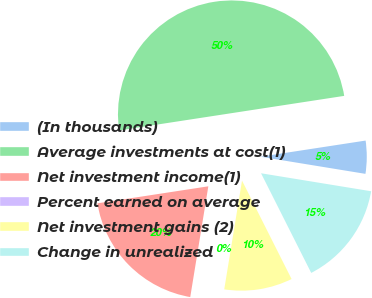Convert chart. <chart><loc_0><loc_0><loc_500><loc_500><pie_chart><fcel>(In thousands)<fcel>Average investments at cost(1)<fcel>Net investment income(1)<fcel>Percent earned on average<fcel>Net investment gains (2)<fcel>Change in unrealized<nl><fcel>5.0%<fcel>50.0%<fcel>20.0%<fcel>0.0%<fcel>10.0%<fcel>15.0%<nl></chart> 